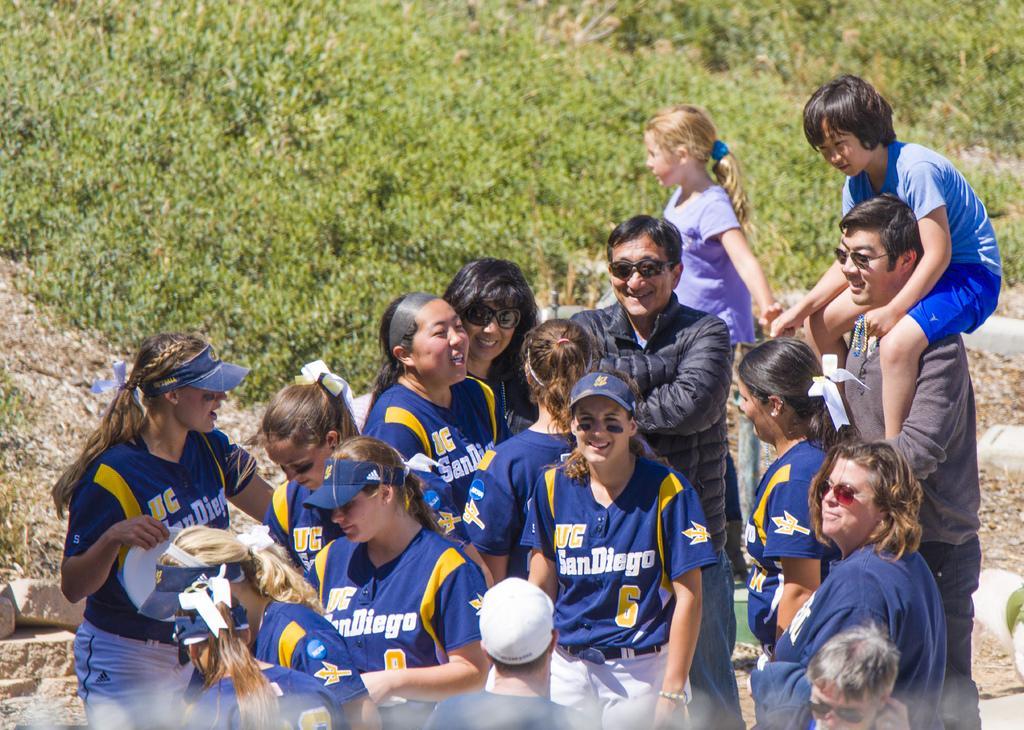Please provide a concise description of this image. In the center of the image we can see people smiling. In the background there is grass. 